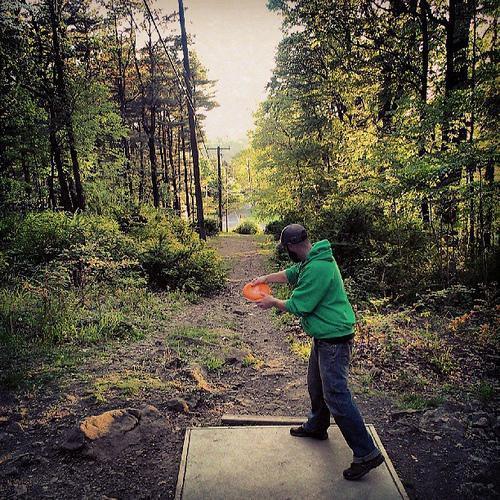How many people are in this picture?
Give a very brief answer. 1. 